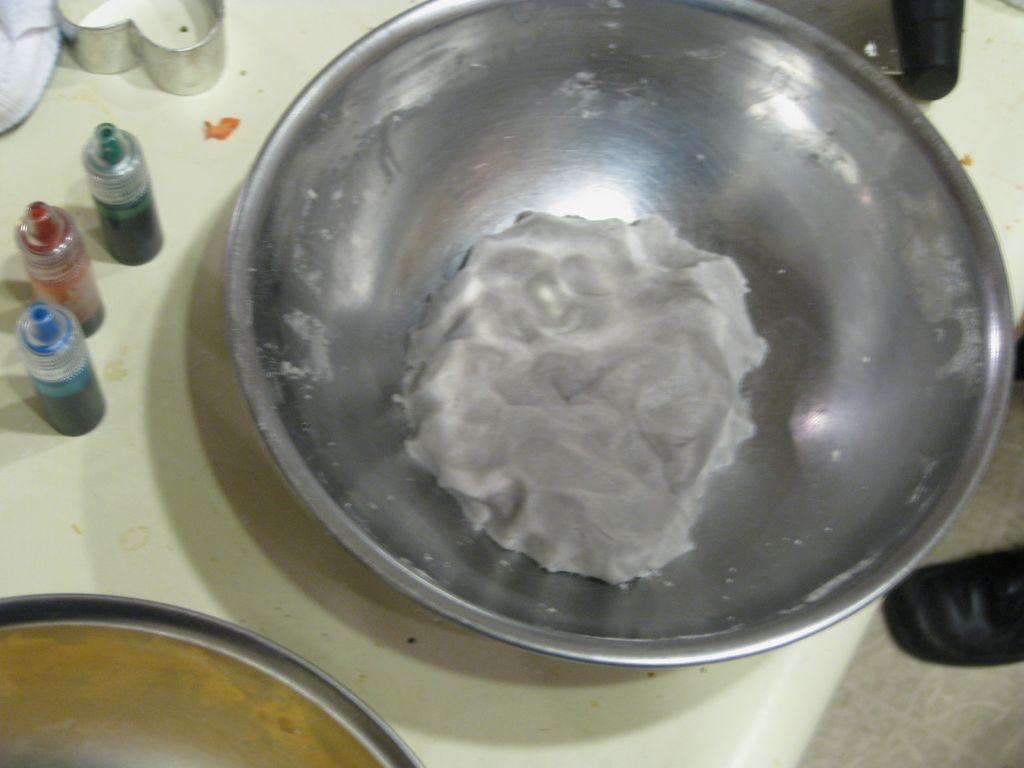How many jars can be seen in the image? There are 3 jars in the image. What else is present in the image besides the jars? There is a cloth, a big bowl with a food item, and a shoe visible on the right side of the image. Where is the big bowl placed in the image? The bowl is placed on a table. What type of tooth is visible in the image? There is no tooth present in the image. What is the reaction of the person in the image when they receive a shock? There is no person present in the image, so it is impossible to determine their reaction to a shock. 